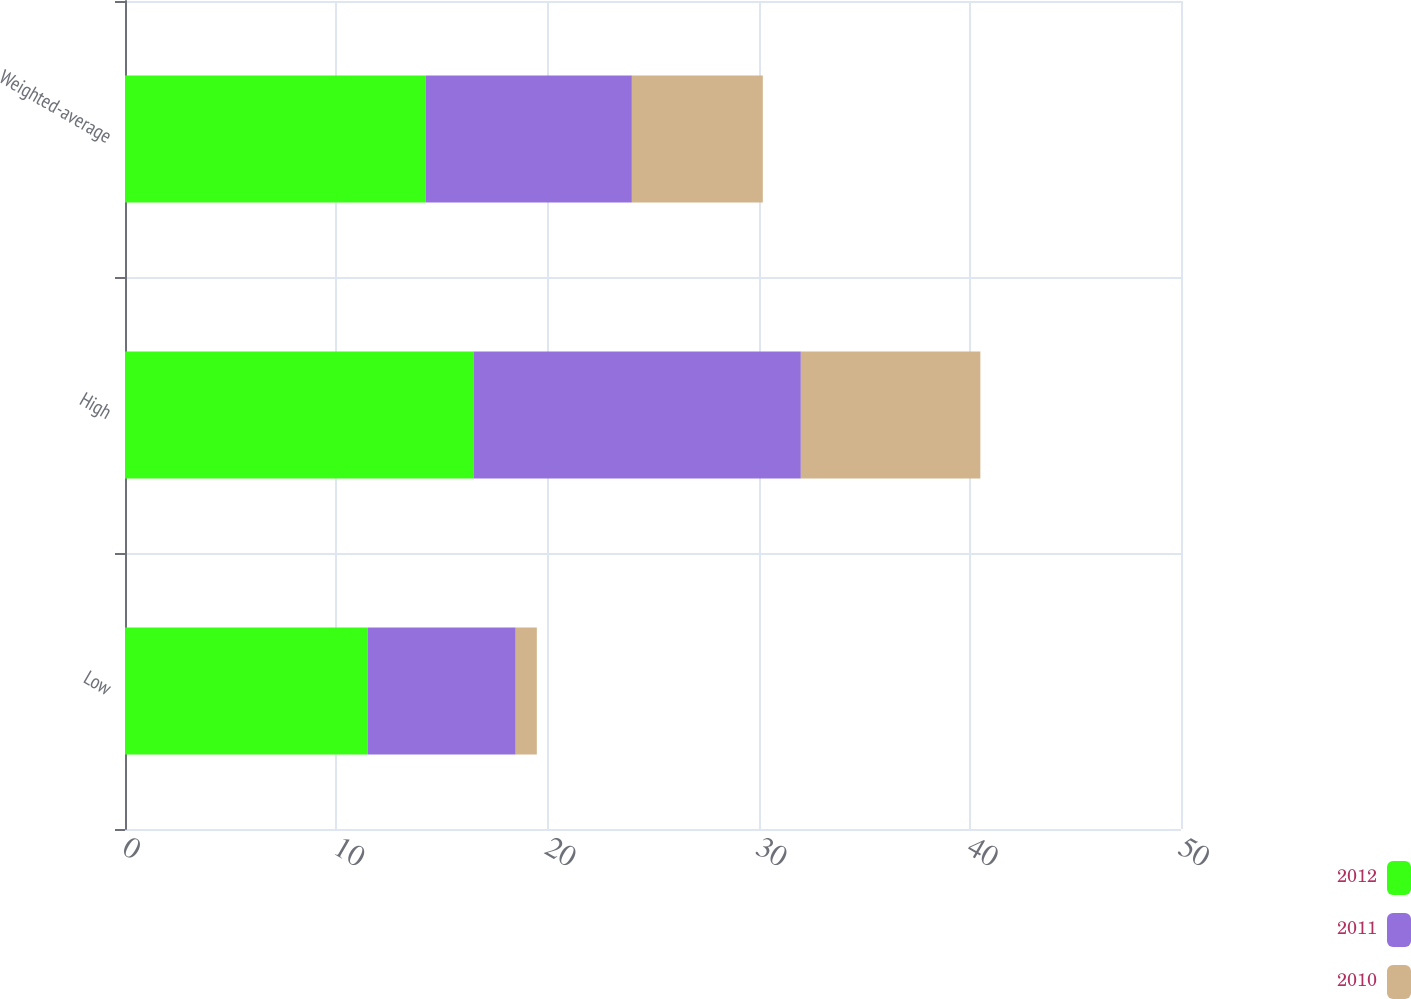<chart> <loc_0><loc_0><loc_500><loc_500><stacked_bar_chart><ecel><fcel>Low<fcel>High<fcel>Weighted-average<nl><fcel>2012<fcel>11.5<fcel>16.5<fcel>14.23<nl><fcel>2011<fcel>7<fcel>15.5<fcel>9.77<nl><fcel>2010<fcel>1<fcel>8.5<fcel>6.2<nl></chart> 